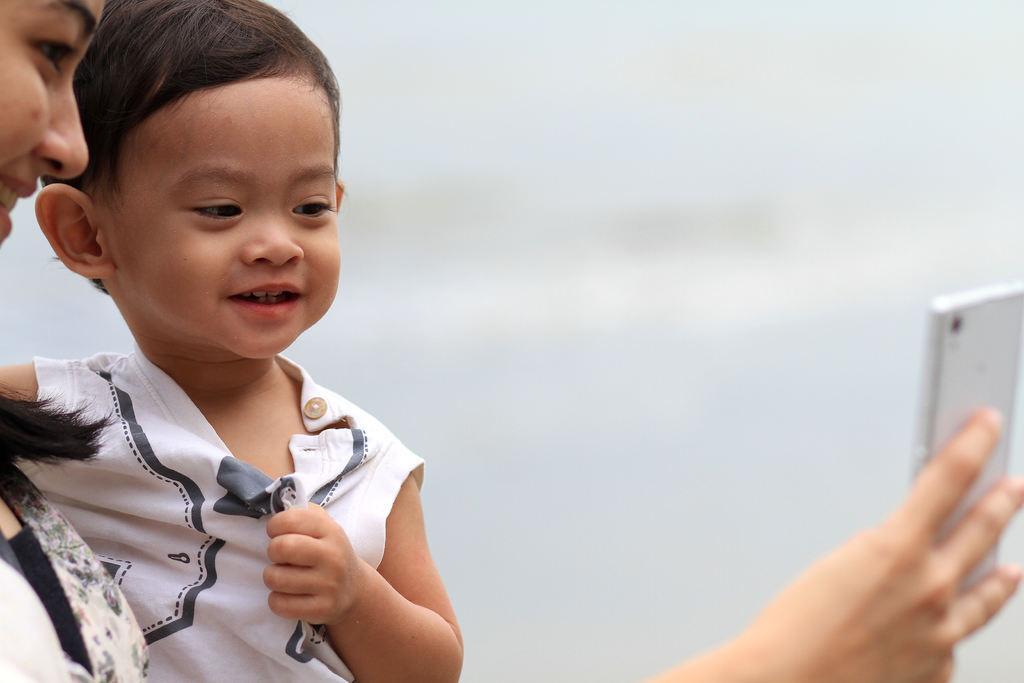How would you summarize this image in a sentence or two? In this image I can see two people. Among them one person is holding the mobile. 